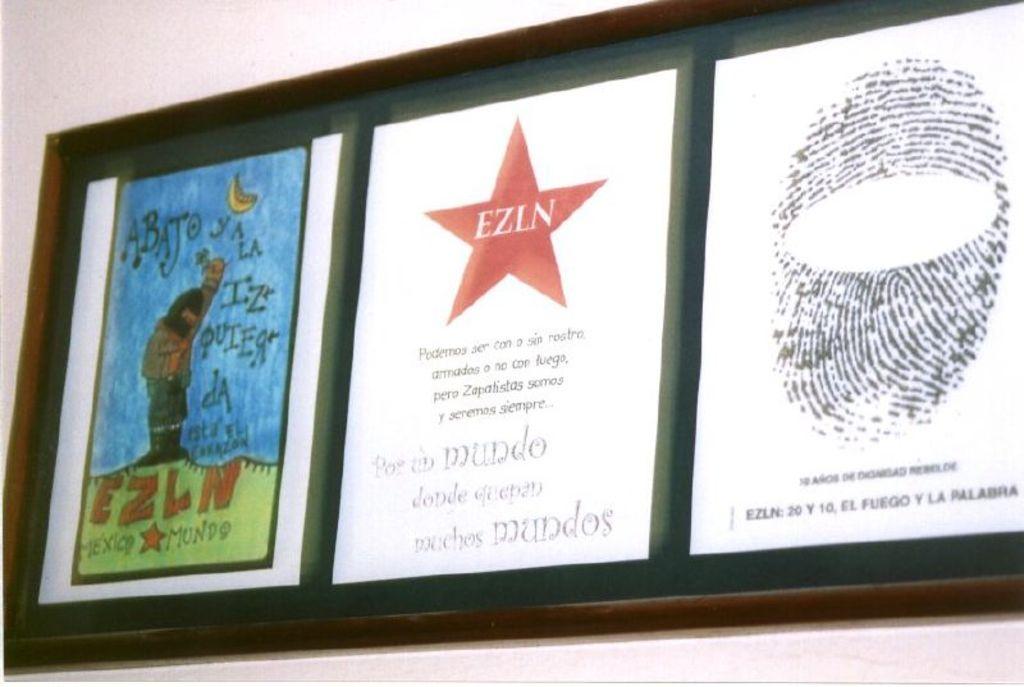What does it say in the star?
Provide a short and direct response. Ezln. What country is written in the first art piece?
Keep it short and to the point. Mexico. 